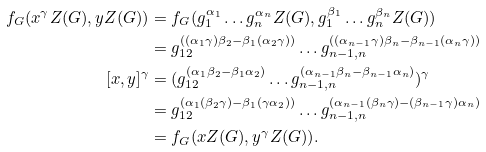<formula> <loc_0><loc_0><loc_500><loc_500>f _ { G } ( x ^ { \gamma } Z ( G ) , y Z ( G ) ) & = f _ { G } ( g _ { 1 } ^ { \alpha _ { 1 } } \dots g _ { n } ^ { \alpha _ { n } } Z ( G ) , g _ { 1 } ^ { \beta _ { 1 } } \dots g _ { n } ^ { \beta _ { n } } Z ( G ) ) \\ & = g _ { 1 2 } ^ { ( ( \alpha _ { 1 } \gamma ) \beta _ { 2 } - \beta _ { 1 } ( \alpha _ { 2 } \gamma ) ) } \dots g _ { n - 1 , n } ^ { ( ( \alpha _ { n - 1 } \gamma ) \beta _ { n } - \beta _ { n - 1 } ( \alpha _ { n } \gamma ) ) } \\ [ x , y ] ^ { \gamma } & = ( g _ { 1 2 } ^ { ( \alpha _ { 1 } \beta _ { 2 } - \beta _ { 1 } \alpha _ { 2 } ) } \dots g _ { n - 1 , n } ^ { ( \alpha _ { n - 1 } \beta _ { n } - \beta _ { n - 1 } \alpha _ { n } ) } ) ^ { \gamma } \\ & = g _ { 1 2 } ^ { ( \alpha _ { 1 } ( \beta _ { 2 } \gamma ) - \beta _ { 1 } ( \gamma \alpha _ { 2 } ) ) } \dots g _ { n - 1 , n } ^ { ( \alpha _ { n - 1 } ( \beta _ { n } \gamma ) - ( \beta _ { n - 1 } \gamma ) \alpha _ { n } ) } \\ & = f _ { G } ( x Z ( G ) , y ^ { \gamma } Z ( G ) ) .</formula> 